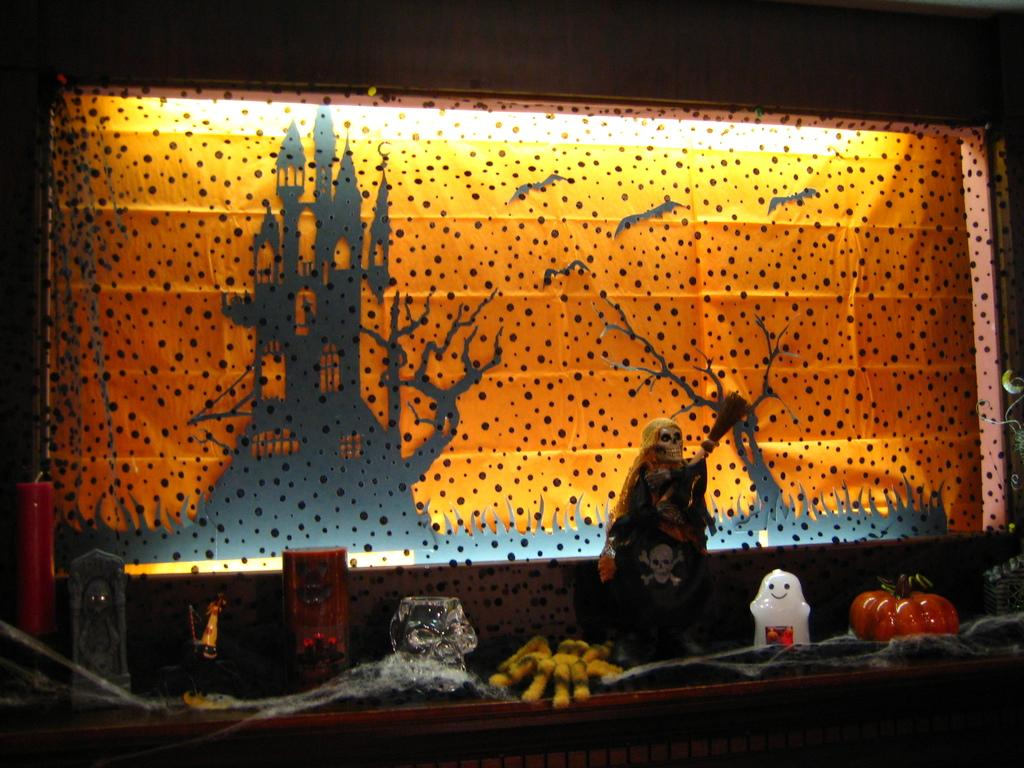What is on the wall in the image? There is wallpaper on the wall in the image. What can be seen in front of the wallpaper? There are toys and statues in front of the wallpaper. What is attached to the wall? There is a candle on the wall. What is depicted on the wallpaper? The wallpaper features a castle. What type of mint can be seen growing near the toys in the image? There is no mint present in the image; it features wallpaper, toys, statues, a candle, and a castle-themed design. 